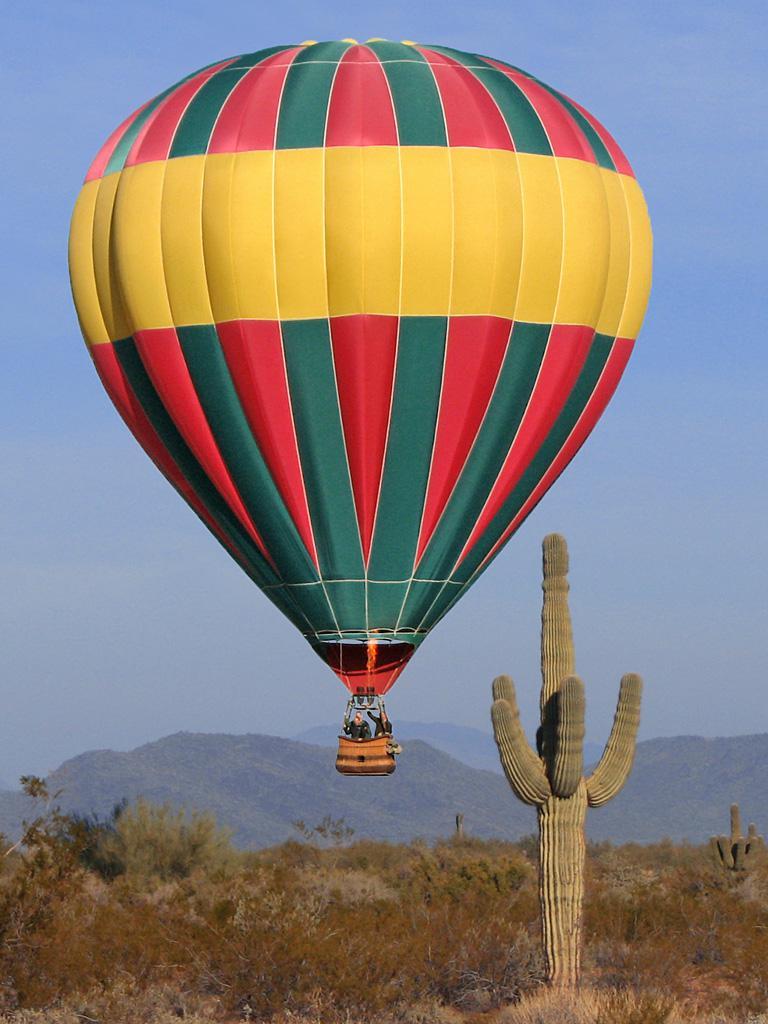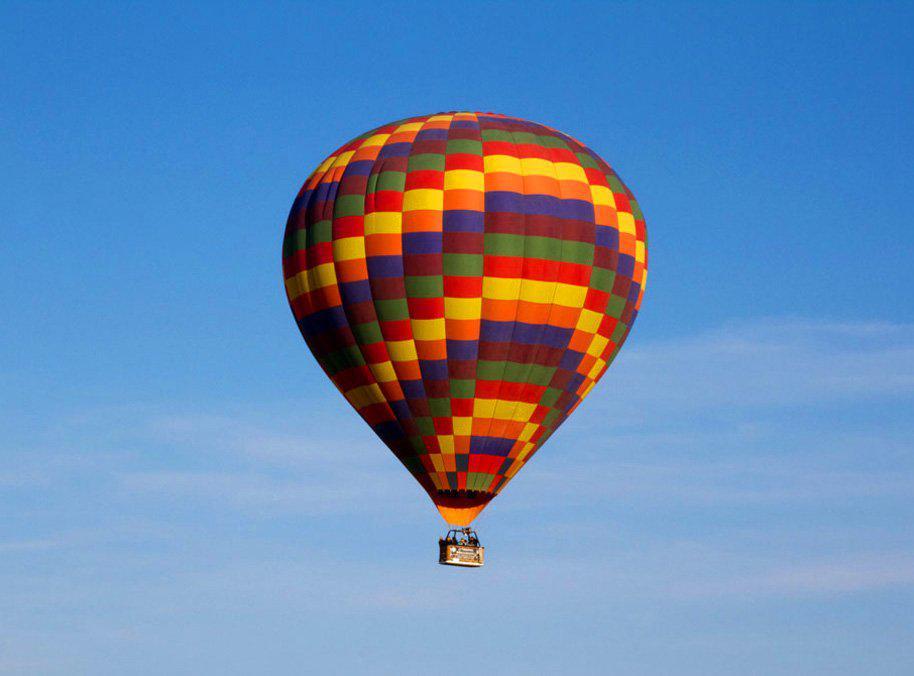The first image is the image on the left, the second image is the image on the right. Assess this claim about the two images: "Two hot air balloons are predominantly red and have baskets for passengers.". Correct or not? Answer yes or no. No. 